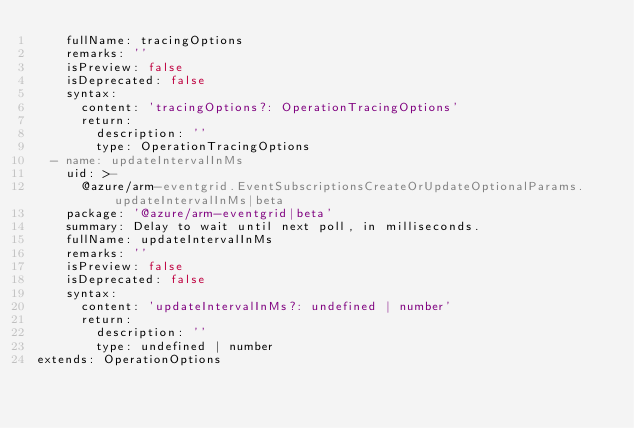<code> <loc_0><loc_0><loc_500><loc_500><_YAML_>    fullName: tracingOptions
    remarks: ''
    isPreview: false
    isDeprecated: false
    syntax:
      content: 'tracingOptions?: OperationTracingOptions'
      return:
        description: ''
        type: OperationTracingOptions
  - name: updateIntervalInMs
    uid: >-
      @azure/arm-eventgrid.EventSubscriptionsCreateOrUpdateOptionalParams.updateIntervalInMs|beta
    package: '@azure/arm-eventgrid|beta'
    summary: Delay to wait until next poll, in milliseconds.
    fullName: updateIntervalInMs
    remarks: ''
    isPreview: false
    isDeprecated: false
    syntax:
      content: 'updateIntervalInMs?: undefined | number'
      return:
        description: ''
        type: undefined | number
extends: OperationOptions
</code> 